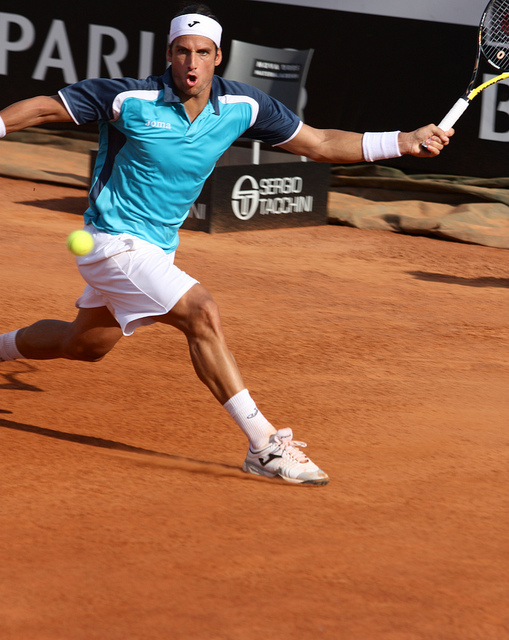Please extract the text content from this image. TACCHN PARI B 